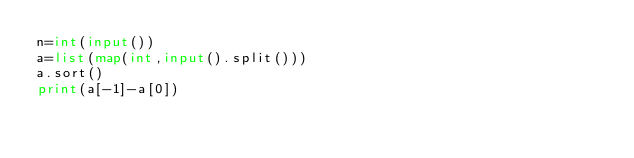Convert code to text. <code><loc_0><loc_0><loc_500><loc_500><_Python_>n=int(input())
a=list(map(int,input().split()))
a.sort()
print(a[-1]-a[0])</code> 